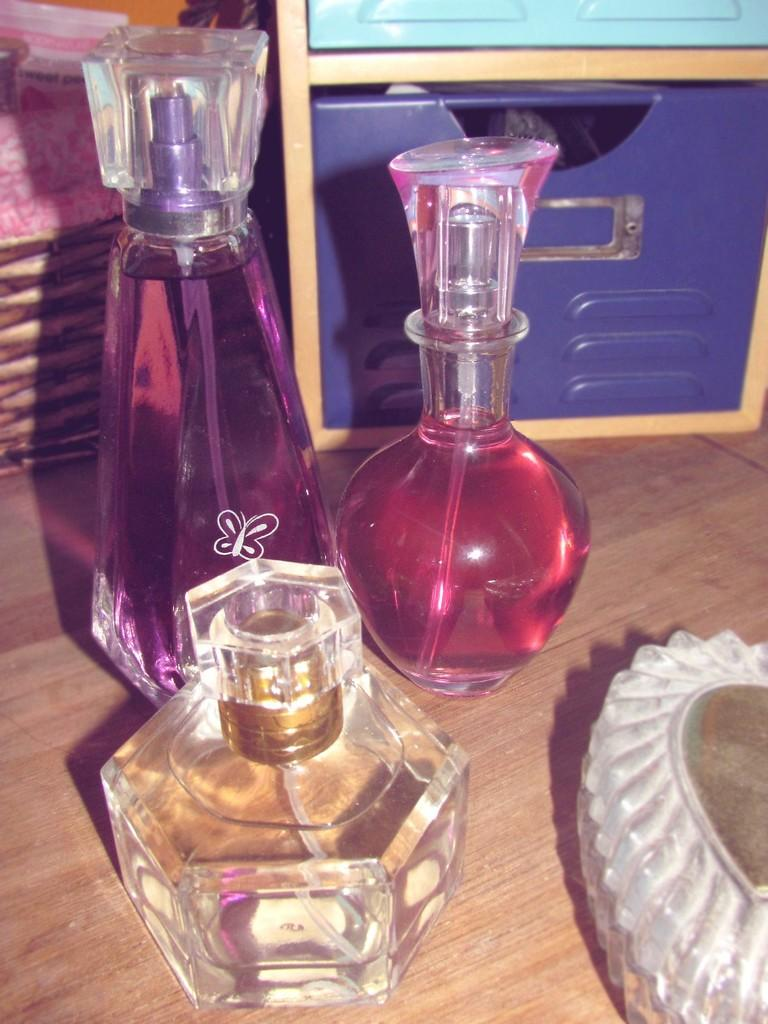What type of products are visible in the image? There are perfumes in the image. What other object can be seen in the image besides the perfumes? There is a box in the image. How many sticks are used to create the afterthought in the image? There is no afterthought or sticks present in the image. What type of ring can be seen on the perfume bottles in the image? There are no rings on the perfume bottles in the image. 